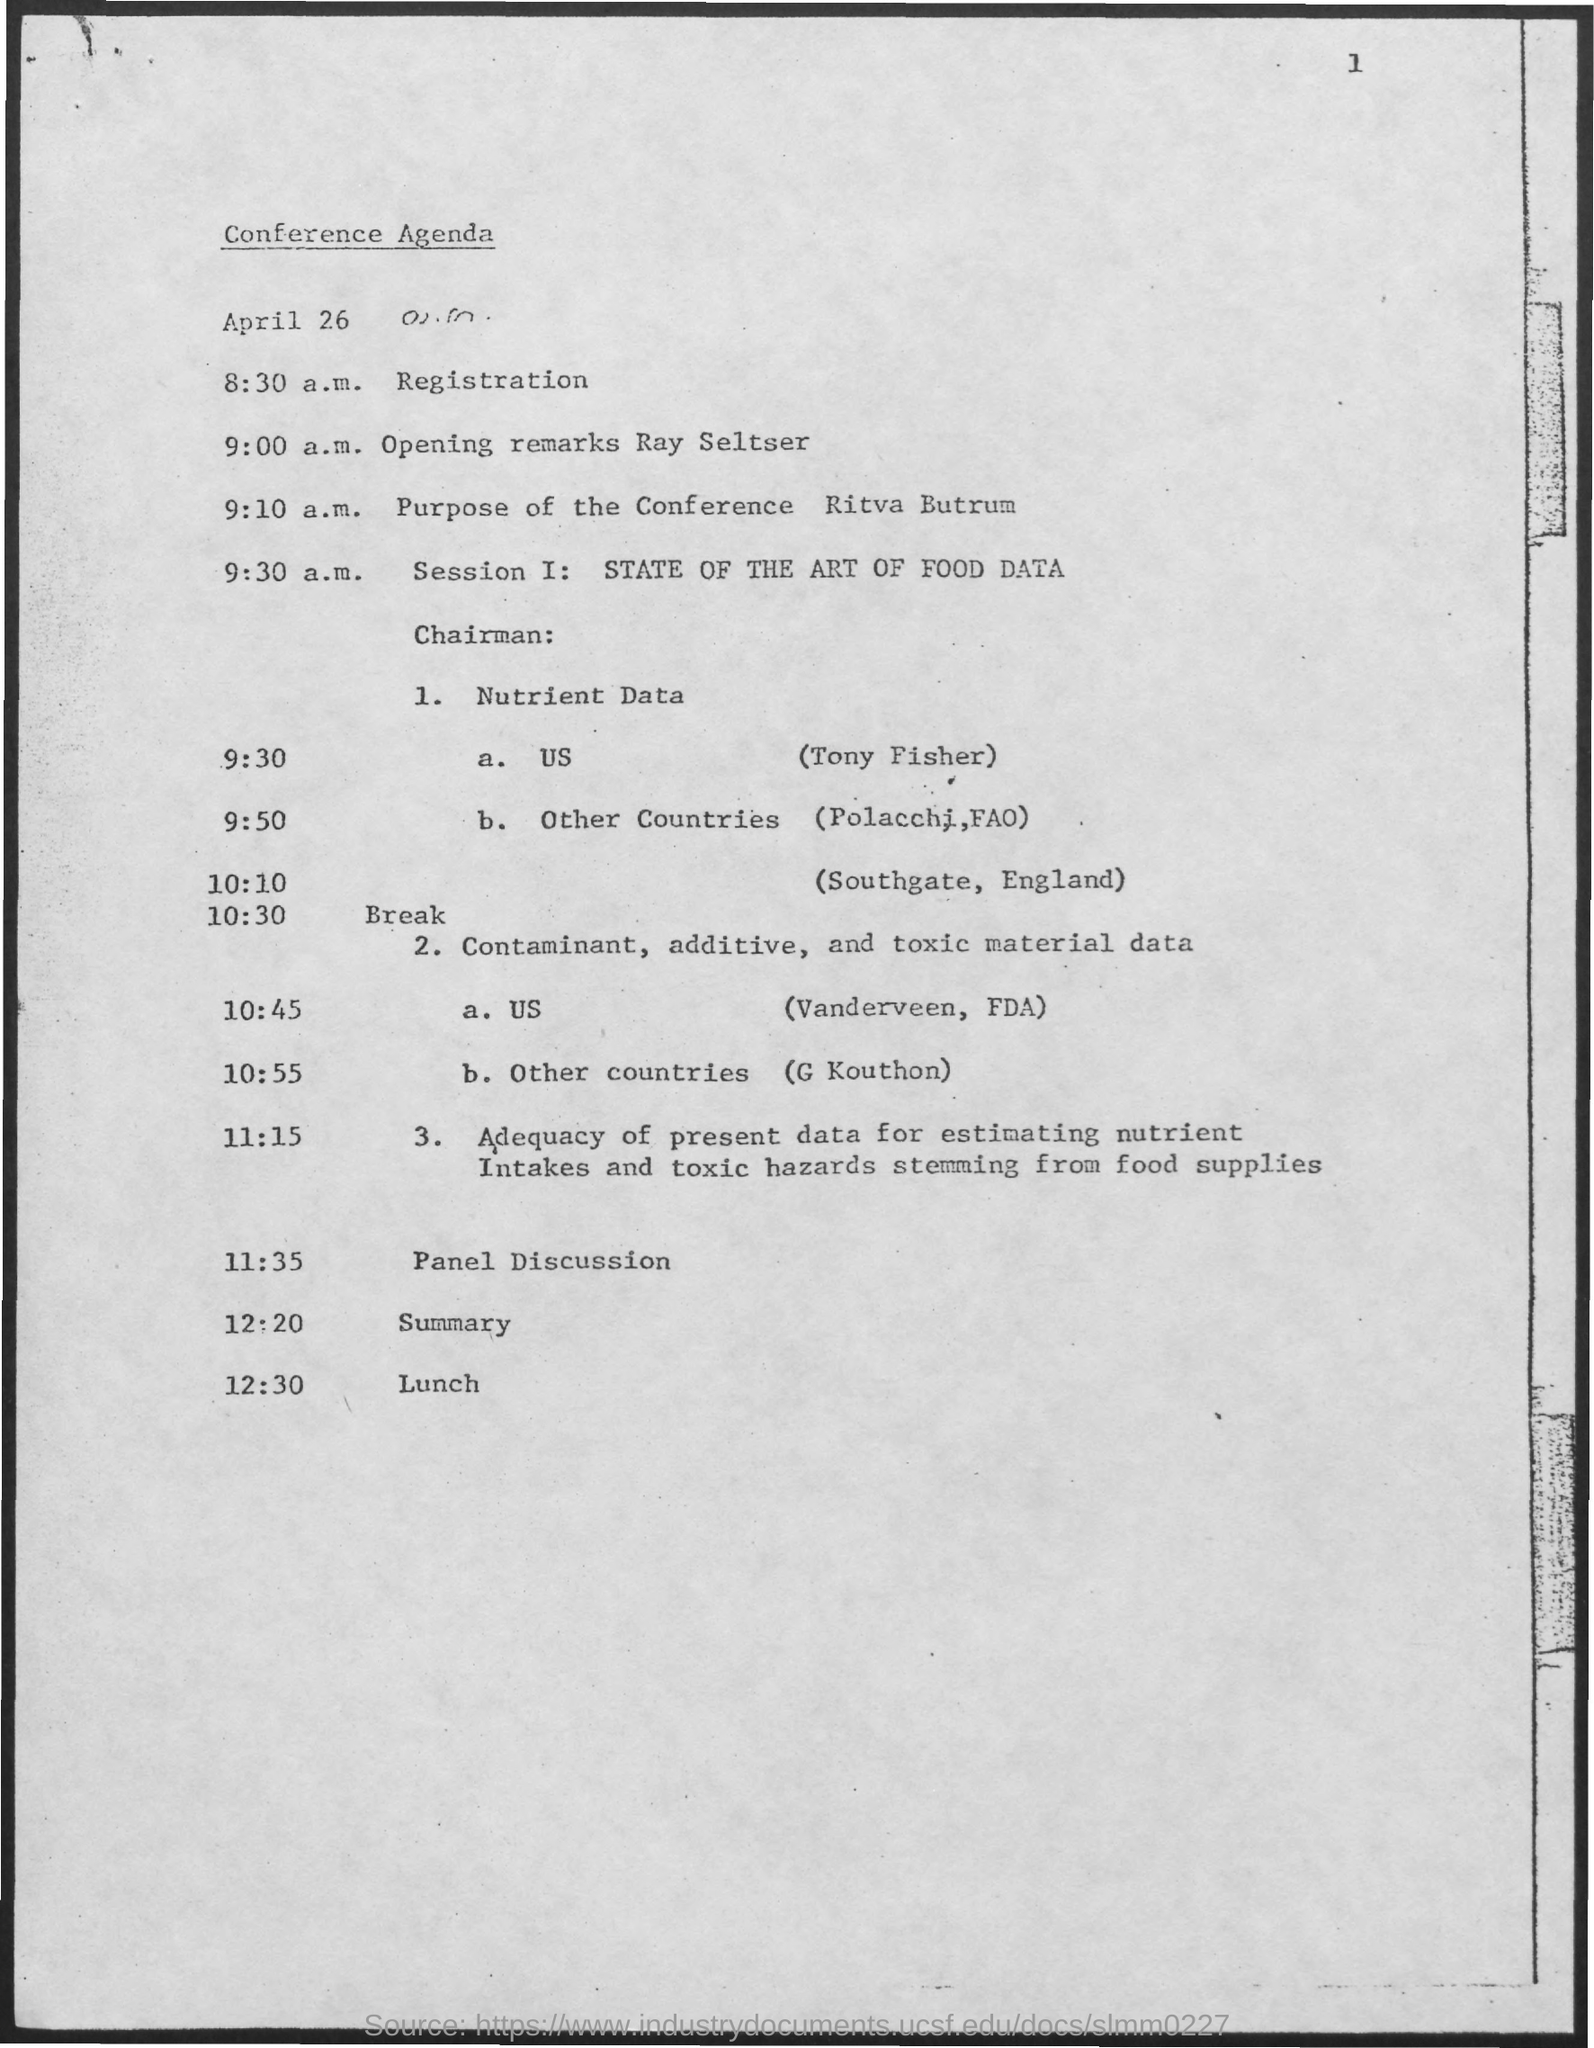The first session is about which topic?
Your response must be concise. State of the art of food data. Tony Fisher is from which country?
Offer a terse response. Us. 